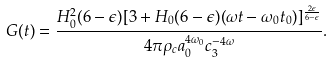Convert formula to latex. <formula><loc_0><loc_0><loc_500><loc_500>G ( t ) = \frac { H ^ { 2 } _ { 0 } ( 6 - \epsilon ) [ 3 + H _ { 0 } ( 6 - \epsilon ) ( \omega t - \omega _ { 0 } t _ { 0 } ) ] ^ { \frac { 2 \epsilon } { 6 - \epsilon } } } { 4 \pi \rho _ { c } a ^ { 4 \omega _ { 0 } } _ { 0 } c ^ { - 4 \omega } _ { 3 } } .</formula> 